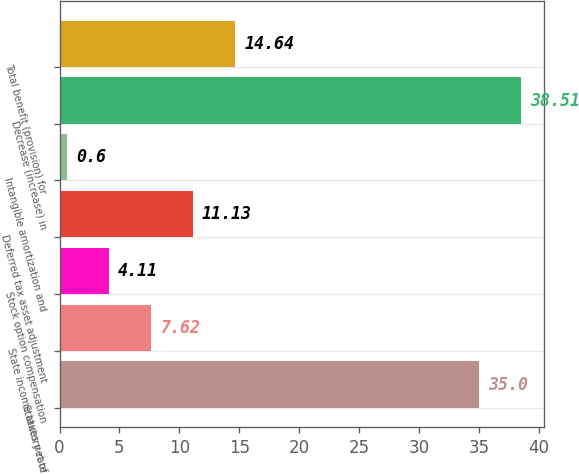<chart> <loc_0><loc_0><loc_500><loc_500><bar_chart><fcel>Statutory rate<fcel>State income taxes net of<fcel>Stock option compensation<fcel>Deferred tax asset adjustment<fcel>Intangible amortization and<fcel>Decrease (increase) in<fcel>Total benefit (provision) for<nl><fcel>35<fcel>7.62<fcel>4.11<fcel>11.13<fcel>0.6<fcel>38.51<fcel>14.64<nl></chart> 